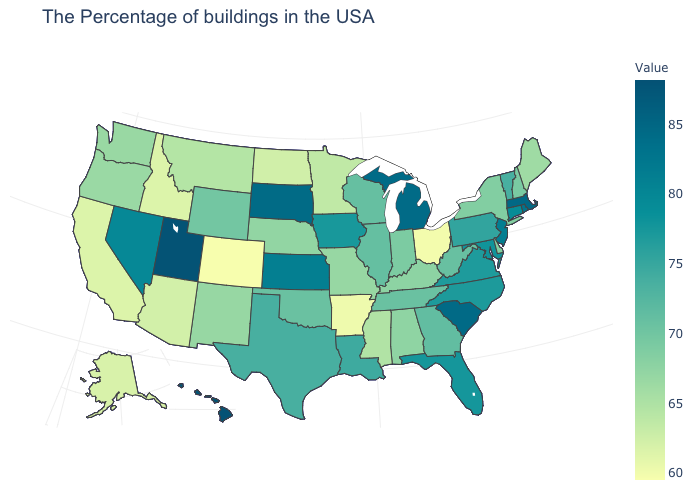Which states hav the highest value in the South?
Concise answer only. South Carolina. Does Hawaii have the highest value in the USA?
Keep it brief. Yes. 